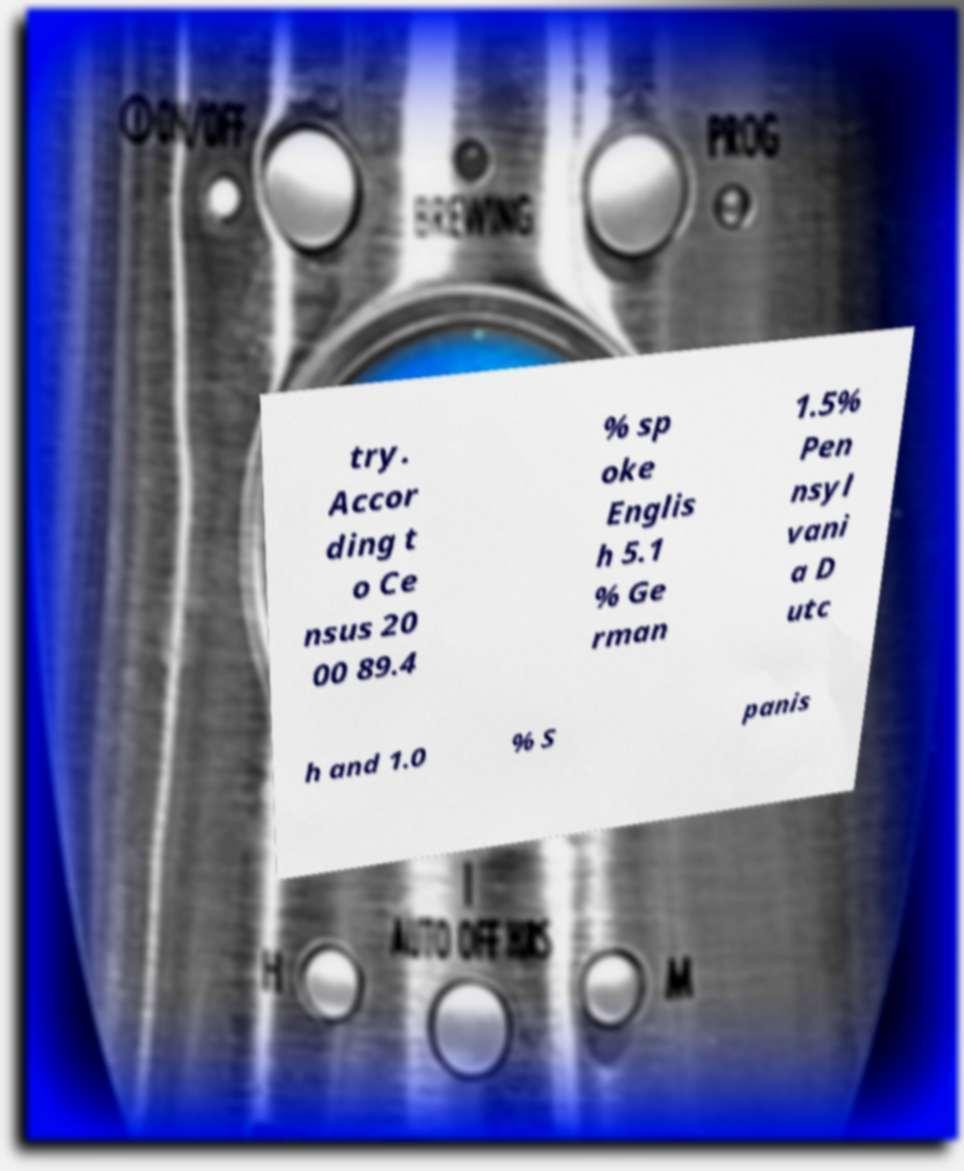I need the written content from this picture converted into text. Can you do that? try. Accor ding t o Ce nsus 20 00 89.4 % sp oke Englis h 5.1 % Ge rman 1.5% Pen nsyl vani a D utc h and 1.0 % S panis 